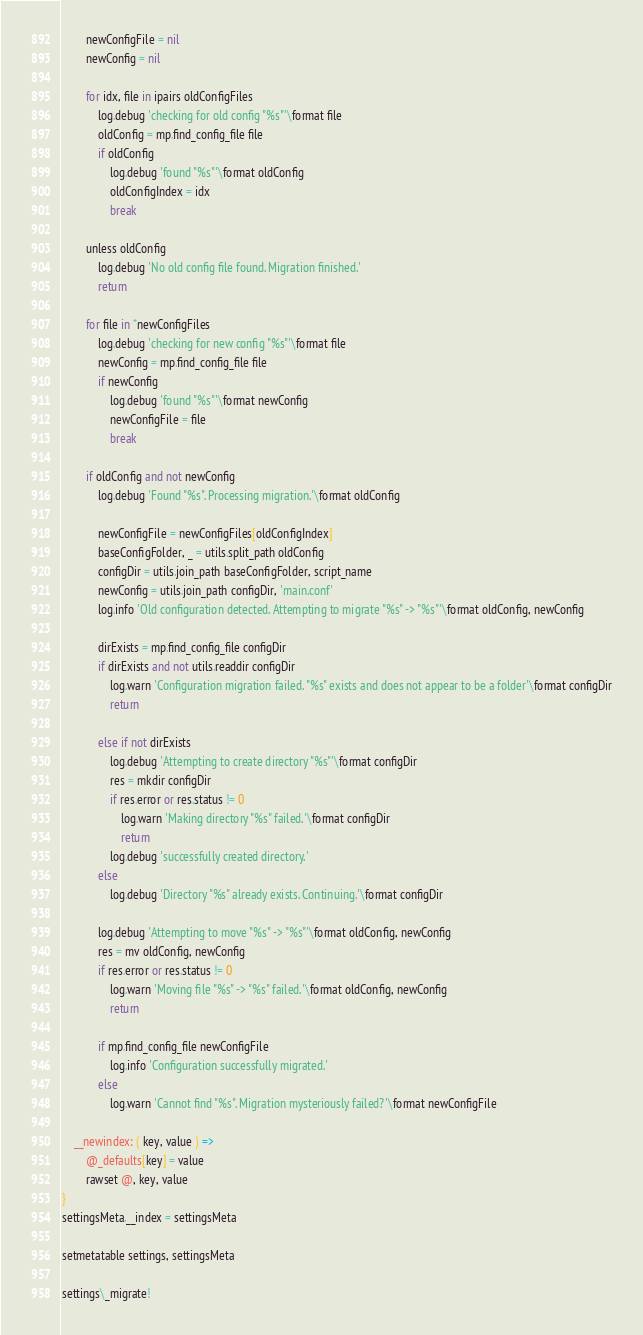Convert code to text. <code><loc_0><loc_0><loc_500><loc_500><_MoonScript_>		newConfigFile = nil
		newConfig = nil

		for idx, file in ipairs oldConfigFiles
			log.debug 'checking for old config "%s"'\format file
			oldConfig = mp.find_config_file file
			if oldConfig
				log.debug 'found "%s"'\format oldConfig
				oldConfigIndex = idx
				break

		unless oldConfig
			log.debug 'No old config file found. Migration finished.'
			return

		for file in *newConfigFiles
			log.debug 'checking for new config "%s"'\format file
			newConfig = mp.find_config_file file
			if newConfig
				log.debug 'found "%s"'\format newConfig
				newConfigFile = file
				break

		if oldConfig and not newConfig
			log.debug 'Found "%s". Processing migration.'\format oldConfig

			newConfigFile = newConfigFiles[oldConfigIndex]
			baseConfigFolder, _ = utils.split_path oldConfig
			configDir = utils.join_path baseConfigFolder, script_name
			newConfig = utils.join_path configDir, 'main.conf'
			log.info 'Old configuration detected. Attempting to migrate "%s" -> "%s"'\format oldConfig, newConfig

			dirExists = mp.find_config_file configDir
			if dirExists and not utils.readdir configDir
				log.warn 'Configuration migration failed. "%s" exists and does not appear to be a folder'\format configDir
				return

			else if not dirExists
				log.debug 'Attempting to create directory "%s"'\format configDir
				res = mkdir configDir
				if res.error or res.status != 0
					log.warn 'Making directory "%s" failed.'\format configDir
					return
				log.debug 'successfully created directory.'
			else
				log.debug 'Directory "%s" already exists. Continuing.'\format configDir

			log.debug 'Attempting to move "%s" -> "%s"'\format oldConfig, newConfig
			res = mv oldConfig, newConfig
			if res.error or res.status != 0
				log.warn 'Moving file "%s" -> "%s" failed.'\format oldConfig, newConfig
				return

			if mp.find_config_file newConfigFile
				log.info 'Configuration successfully migrated.'
			else
				log.warn 'Cannot find "%s". Migration mysteriously failed?'\format newConfigFile

	__newindex: ( key, value ) =>
		@_defaults[key] = value
		rawset @, key, value
}
settingsMeta.__index = settingsMeta

setmetatable settings, settingsMeta

settings\_migrate!
</code> 